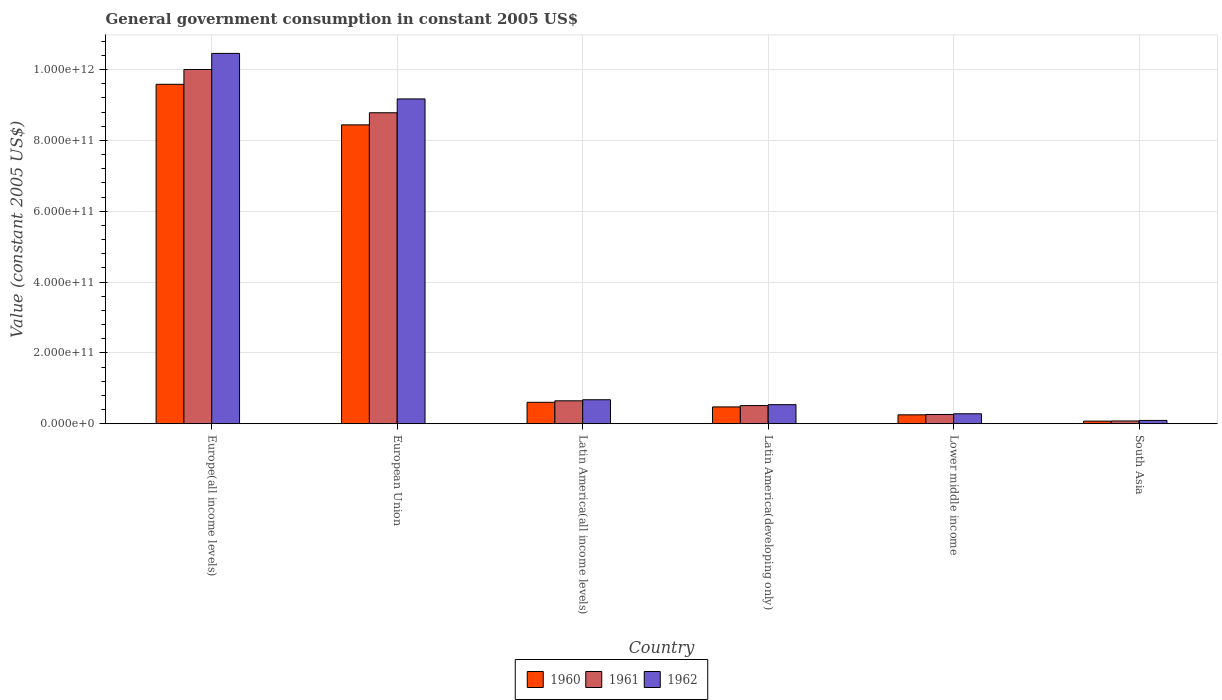Are the number of bars per tick equal to the number of legend labels?
Keep it short and to the point. Yes. How many bars are there on the 4th tick from the right?
Ensure brevity in your answer.  3. What is the label of the 2nd group of bars from the left?
Ensure brevity in your answer.  European Union. What is the government conusmption in 1961 in Latin America(developing only)?
Provide a short and direct response. 5.13e+1. Across all countries, what is the maximum government conusmption in 1960?
Ensure brevity in your answer.  9.58e+11. Across all countries, what is the minimum government conusmption in 1960?
Offer a terse response. 7.34e+09. In which country was the government conusmption in 1962 maximum?
Your answer should be compact. Europe(all income levels). What is the total government conusmption in 1962 in the graph?
Offer a very short reply. 2.12e+12. What is the difference between the government conusmption in 1960 in Latin America(developing only) and that in South Asia?
Ensure brevity in your answer.  4.01e+1. What is the difference between the government conusmption in 1962 in Europe(all income levels) and the government conusmption in 1961 in South Asia?
Offer a very short reply. 1.04e+12. What is the average government conusmption in 1962 per country?
Offer a very short reply. 3.54e+11. What is the difference between the government conusmption of/in 1961 and government conusmption of/in 1962 in Europe(all income levels)?
Ensure brevity in your answer.  -4.54e+1. In how many countries, is the government conusmption in 1960 greater than 760000000000 US$?
Provide a succinct answer. 2. What is the ratio of the government conusmption in 1962 in Latin America(all income levels) to that in Lower middle income?
Offer a terse response. 2.41. Is the government conusmption in 1962 in European Union less than that in South Asia?
Ensure brevity in your answer.  No. What is the difference between the highest and the second highest government conusmption in 1962?
Your answer should be compact. 1.29e+11. What is the difference between the highest and the lowest government conusmption in 1962?
Offer a very short reply. 1.04e+12. In how many countries, is the government conusmption in 1961 greater than the average government conusmption in 1961 taken over all countries?
Your answer should be compact. 2. Is the sum of the government conusmption in 1960 in European Union and Lower middle income greater than the maximum government conusmption in 1962 across all countries?
Offer a very short reply. No. Is it the case that in every country, the sum of the government conusmption in 1962 and government conusmption in 1960 is greater than the government conusmption in 1961?
Give a very brief answer. Yes. What is the difference between two consecutive major ticks on the Y-axis?
Offer a terse response. 2.00e+11. Does the graph contain any zero values?
Your answer should be very brief. No. Does the graph contain grids?
Your answer should be compact. Yes. Where does the legend appear in the graph?
Your answer should be compact. Bottom center. What is the title of the graph?
Your answer should be compact. General government consumption in constant 2005 US$. What is the label or title of the X-axis?
Provide a short and direct response. Country. What is the label or title of the Y-axis?
Provide a short and direct response. Value (constant 2005 US$). What is the Value (constant 2005 US$) in 1960 in Europe(all income levels)?
Offer a very short reply. 9.58e+11. What is the Value (constant 2005 US$) of 1961 in Europe(all income levels)?
Your answer should be very brief. 1.00e+12. What is the Value (constant 2005 US$) of 1962 in Europe(all income levels)?
Ensure brevity in your answer.  1.05e+12. What is the Value (constant 2005 US$) in 1960 in European Union?
Provide a short and direct response. 8.44e+11. What is the Value (constant 2005 US$) in 1961 in European Union?
Provide a short and direct response. 8.78e+11. What is the Value (constant 2005 US$) of 1962 in European Union?
Keep it short and to the point. 9.17e+11. What is the Value (constant 2005 US$) in 1960 in Latin America(all income levels)?
Offer a terse response. 6.06e+1. What is the Value (constant 2005 US$) in 1961 in Latin America(all income levels)?
Make the answer very short. 6.47e+1. What is the Value (constant 2005 US$) of 1962 in Latin America(all income levels)?
Your answer should be compact. 6.77e+1. What is the Value (constant 2005 US$) in 1960 in Latin America(developing only)?
Your response must be concise. 4.75e+1. What is the Value (constant 2005 US$) of 1961 in Latin America(developing only)?
Your answer should be compact. 5.13e+1. What is the Value (constant 2005 US$) in 1962 in Latin America(developing only)?
Provide a succinct answer. 5.38e+1. What is the Value (constant 2005 US$) in 1960 in Lower middle income?
Offer a terse response. 2.52e+1. What is the Value (constant 2005 US$) in 1961 in Lower middle income?
Offer a very short reply. 2.61e+1. What is the Value (constant 2005 US$) in 1962 in Lower middle income?
Ensure brevity in your answer.  2.81e+1. What is the Value (constant 2005 US$) in 1960 in South Asia?
Offer a terse response. 7.34e+09. What is the Value (constant 2005 US$) in 1961 in South Asia?
Give a very brief answer. 7.82e+09. What is the Value (constant 2005 US$) in 1962 in South Asia?
Give a very brief answer. 9.32e+09. Across all countries, what is the maximum Value (constant 2005 US$) in 1960?
Provide a short and direct response. 9.58e+11. Across all countries, what is the maximum Value (constant 2005 US$) in 1961?
Offer a very short reply. 1.00e+12. Across all countries, what is the maximum Value (constant 2005 US$) of 1962?
Offer a very short reply. 1.05e+12. Across all countries, what is the minimum Value (constant 2005 US$) in 1960?
Offer a very short reply. 7.34e+09. Across all countries, what is the minimum Value (constant 2005 US$) of 1961?
Keep it short and to the point. 7.82e+09. Across all countries, what is the minimum Value (constant 2005 US$) of 1962?
Your answer should be compact. 9.32e+09. What is the total Value (constant 2005 US$) in 1960 in the graph?
Your answer should be compact. 1.94e+12. What is the total Value (constant 2005 US$) in 1961 in the graph?
Your response must be concise. 2.03e+12. What is the total Value (constant 2005 US$) in 1962 in the graph?
Make the answer very short. 2.12e+12. What is the difference between the Value (constant 2005 US$) of 1960 in Europe(all income levels) and that in European Union?
Offer a terse response. 1.15e+11. What is the difference between the Value (constant 2005 US$) of 1961 in Europe(all income levels) and that in European Union?
Keep it short and to the point. 1.22e+11. What is the difference between the Value (constant 2005 US$) of 1962 in Europe(all income levels) and that in European Union?
Your answer should be compact. 1.29e+11. What is the difference between the Value (constant 2005 US$) in 1960 in Europe(all income levels) and that in Latin America(all income levels)?
Ensure brevity in your answer.  8.98e+11. What is the difference between the Value (constant 2005 US$) of 1961 in Europe(all income levels) and that in Latin America(all income levels)?
Your response must be concise. 9.35e+11. What is the difference between the Value (constant 2005 US$) in 1962 in Europe(all income levels) and that in Latin America(all income levels)?
Offer a very short reply. 9.78e+11. What is the difference between the Value (constant 2005 US$) in 1960 in Europe(all income levels) and that in Latin America(developing only)?
Your response must be concise. 9.11e+11. What is the difference between the Value (constant 2005 US$) of 1961 in Europe(all income levels) and that in Latin America(developing only)?
Offer a very short reply. 9.49e+11. What is the difference between the Value (constant 2005 US$) of 1962 in Europe(all income levels) and that in Latin America(developing only)?
Make the answer very short. 9.92e+11. What is the difference between the Value (constant 2005 US$) in 1960 in Europe(all income levels) and that in Lower middle income?
Ensure brevity in your answer.  9.33e+11. What is the difference between the Value (constant 2005 US$) in 1961 in Europe(all income levels) and that in Lower middle income?
Your response must be concise. 9.74e+11. What is the difference between the Value (constant 2005 US$) of 1962 in Europe(all income levels) and that in Lower middle income?
Your response must be concise. 1.02e+12. What is the difference between the Value (constant 2005 US$) in 1960 in Europe(all income levels) and that in South Asia?
Offer a terse response. 9.51e+11. What is the difference between the Value (constant 2005 US$) in 1961 in Europe(all income levels) and that in South Asia?
Provide a short and direct response. 9.92e+11. What is the difference between the Value (constant 2005 US$) in 1962 in Europe(all income levels) and that in South Asia?
Provide a short and direct response. 1.04e+12. What is the difference between the Value (constant 2005 US$) of 1960 in European Union and that in Latin America(all income levels)?
Give a very brief answer. 7.83e+11. What is the difference between the Value (constant 2005 US$) in 1961 in European Union and that in Latin America(all income levels)?
Make the answer very short. 8.13e+11. What is the difference between the Value (constant 2005 US$) of 1962 in European Union and that in Latin America(all income levels)?
Your response must be concise. 8.49e+11. What is the difference between the Value (constant 2005 US$) of 1960 in European Union and that in Latin America(developing only)?
Your answer should be very brief. 7.96e+11. What is the difference between the Value (constant 2005 US$) in 1961 in European Union and that in Latin America(developing only)?
Provide a succinct answer. 8.27e+11. What is the difference between the Value (constant 2005 US$) in 1962 in European Union and that in Latin America(developing only)?
Make the answer very short. 8.63e+11. What is the difference between the Value (constant 2005 US$) in 1960 in European Union and that in Lower middle income?
Keep it short and to the point. 8.19e+11. What is the difference between the Value (constant 2005 US$) of 1961 in European Union and that in Lower middle income?
Your answer should be very brief. 8.52e+11. What is the difference between the Value (constant 2005 US$) in 1962 in European Union and that in Lower middle income?
Keep it short and to the point. 8.89e+11. What is the difference between the Value (constant 2005 US$) of 1960 in European Union and that in South Asia?
Your answer should be very brief. 8.36e+11. What is the difference between the Value (constant 2005 US$) of 1961 in European Union and that in South Asia?
Your response must be concise. 8.70e+11. What is the difference between the Value (constant 2005 US$) of 1962 in European Union and that in South Asia?
Provide a succinct answer. 9.08e+11. What is the difference between the Value (constant 2005 US$) of 1960 in Latin America(all income levels) and that in Latin America(developing only)?
Your response must be concise. 1.31e+1. What is the difference between the Value (constant 2005 US$) of 1961 in Latin America(all income levels) and that in Latin America(developing only)?
Provide a short and direct response. 1.35e+1. What is the difference between the Value (constant 2005 US$) of 1962 in Latin America(all income levels) and that in Latin America(developing only)?
Your answer should be compact. 1.39e+1. What is the difference between the Value (constant 2005 US$) of 1960 in Latin America(all income levels) and that in Lower middle income?
Offer a very short reply. 3.54e+1. What is the difference between the Value (constant 2005 US$) in 1961 in Latin America(all income levels) and that in Lower middle income?
Your answer should be very brief. 3.86e+1. What is the difference between the Value (constant 2005 US$) of 1962 in Latin America(all income levels) and that in Lower middle income?
Offer a terse response. 3.96e+1. What is the difference between the Value (constant 2005 US$) of 1960 in Latin America(all income levels) and that in South Asia?
Ensure brevity in your answer.  5.32e+1. What is the difference between the Value (constant 2005 US$) of 1961 in Latin America(all income levels) and that in South Asia?
Provide a succinct answer. 5.69e+1. What is the difference between the Value (constant 2005 US$) in 1962 in Latin America(all income levels) and that in South Asia?
Give a very brief answer. 5.84e+1. What is the difference between the Value (constant 2005 US$) of 1960 in Latin America(developing only) and that in Lower middle income?
Offer a very short reply. 2.23e+1. What is the difference between the Value (constant 2005 US$) of 1961 in Latin America(developing only) and that in Lower middle income?
Provide a succinct answer. 2.52e+1. What is the difference between the Value (constant 2005 US$) in 1962 in Latin America(developing only) and that in Lower middle income?
Offer a terse response. 2.57e+1. What is the difference between the Value (constant 2005 US$) of 1960 in Latin America(developing only) and that in South Asia?
Keep it short and to the point. 4.01e+1. What is the difference between the Value (constant 2005 US$) in 1961 in Latin America(developing only) and that in South Asia?
Your answer should be very brief. 4.35e+1. What is the difference between the Value (constant 2005 US$) in 1962 in Latin America(developing only) and that in South Asia?
Your answer should be compact. 4.45e+1. What is the difference between the Value (constant 2005 US$) of 1960 in Lower middle income and that in South Asia?
Your answer should be very brief. 1.78e+1. What is the difference between the Value (constant 2005 US$) in 1961 in Lower middle income and that in South Asia?
Your answer should be very brief. 1.83e+1. What is the difference between the Value (constant 2005 US$) in 1962 in Lower middle income and that in South Asia?
Give a very brief answer. 1.88e+1. What is the difference between the Value (constant 2005 US$) in 1960 in Europe(all income levels) and the Value (constant 2005 US$) in 1961 in European Union?
Make the answer very short. 8.03e+1. What is the difference between the Value (constant 2005 US$) of 1960 in Europe(all income levels) and the Value (constant 2005 US$) of 1962 in European Union?
Provide a short and direct response. 4.13e+1. What is the difference between the Value (constant 2005 US$) in 1961 in Europe(all income levels) and the Value (constant 2005 US$) in 1962 in European Union?
Offer a very short reply. 8.31e+1. What is the difference between the Value (constant 2005 US$) of 1960 in Europe(all income levels) and the Value (constant 2005 US$) of 1961 in Latin America(all income levels)?
Provide a succinct answer. 8.94e+11. What is the difference between the Value (constant 2005 US$) of 1960 in Europe(all income levels) and the Value (constant 2005 US$) of 1962 in Latin America(all income levels)?
Give a very brief answer. 8.91e+11. What is the difference between the Value (constant 2005 US$) in 1961 in Europe(all income levels) and the Value (constant 2005 US$) in 1962 in Latin America(all income levels)?
Your response must be concise. 9.32e+11. What is the difference between the Value (constant 2005 US$) in 1960 in Europe(all income levels) and the Value (constant 2005 US$) in 1961 in Latin America(developing only)?
Provide a short and direct response. 9.07e+11. What is the difference between the Value (constant 2005 US$) in 1960 in Europe(all income levels) and the Value (constant 2005 US$) in 1962 in Latin America(developing only)?
Offer a very short reply. 9.05e+11. What is the difference between the Value (constant 2005 US$) of 1961 in Europe(all income levels) and the Value (constant 2005 US$) of 1962 in Latin America(developing only)?
Offer a terse response. 9.46e+11. What is the difference between the Value (constant 2005 US$) of 1960 in Europe(all income levels) and the Value (constant 2005 US$) of 1961 in Lower middle income?
Offer a very short reply. 9.32e+11. What is the difference between the Value (constant 2005 US$) in 1960 in Europe(all income levels) and the Value (constant 2005 US$) in 1962 in Lower middle income?
Give a very brief answer. 9.30e+11. What is the difference between the Value (constant 2005 US$) in 1961 in Europe(all income levels) and the Value (constant 2005 US$) in 1962 in Lower middle income?
Ensure brevity in your answer.  9.72e+11. What is the difference between the Value (constant 2005 US$) in 1960 in Europe(all income levels) and the Value (constant 2005 US$) in 1961 in South Asia?
Your answer should be very brief. 9.51e+11. What is the difference between the Value (constant 2005 US$) in 1960 in Europe(all income levels) and the Value (constant 2005 US$) in 1962 in South Asia?
Offer a very short reply. 9.49e+11. What is the difference between the Value (constant 2005 US$) in 1961 in Europe(all income levels) and the Value (constant 2005 US$) in 1962 in South Asia?
Make the answer very short. 9.91e+11. What is the difference between the Value (constant 2005 US$) in 1960 in European Union and the Value (constant 2005 US$) in 1961 in Latin America(all income levels)?
Provide a succinct answer. 7.79e+11. What is the difference between the Value (constant 2005 US$) of 1960 in European Union and the Value (constant 2005 US$) of 1962 in Latin America(all income levels)?
Your response must be concise. 7.76e+11. What is the difference between the Value (constant 2005 US$) of 1961 in European Union and the Value (constant 2005 US$) of 1962 in Latin America(all income levels)?
Make the answer very short. 8.10e+11. What is the difference between the Value (constant 2005 US$) of 1960 in European Union and the Value (constant 2005 US$) of 1961 in Latin America(developing only)?
Offer a terse response. 7.93e+11. What is the difference between the Value (constant 2005 US$) of 1960 in European Union and the Value (constant 2005 US$) of 1962 in Latin America(developing only)?
Provide a short and direct response. 7.90e+11. What is the difference between the Value (constant 2005 US$) in 1961 in European Union and the Value (constant 2005 US$) in 1962 in Latin America(developing only)?
Your response must be concise. 8.24e+11. What is the difference between the Value (constant 2005 US$) in 1960 in European Union and the Value (constant 2005 US$) in 1961 in Lower middle income?
Provide a short and direct response. 8.18e+11. What is the difference between the Value (constant 2005 US$) in 1960 in European Union and the Value (constant 2005 US$) in 1962 in Lower middle income?
Your answer should be compact. 8.16e+11. What is the difference between the Value (constant 2005 US$) of 1961 in European Union and the Value (constant 2005 US$) of 1962 in Lower middle income?
Keep it short and to the point. 8.50e+11. What is the difference between the Value (constant 2005 US$) in 1960 in European Union and the Value (constant 2005 US$) in 1961 in South Asia?
Keep it short and to the point. 8.36e+11. What is the difference between the Value (constant 2005 US$) in 1960 in European Union and the Value (constant 2005 US$) in 1962 in South Asia?
Offer a terse response. 8.35e+11. What is the difference between the Value (constant 2005 US$) in 1961 in European Union and the Value (constant 2005 US$) in 1962 in South Asia?
Offer a very short reply. 8.69e+11. What is the difference between the Value (constant 2005 US$) of 1960 in Latin America(all income levels) and the Value (constant 2005 US$) of 1961 in Latin America(developing only)?
Your response must be concise. 9.29e+09. What is the difference between the Value (constant 2005 US$) in 1960 in Latin America(all income levels) and the Value (constant 2005 US$) in 1962 in Latin America(developing only)?
Make the answer very short. 6.76e+09. What is the difference between the Value (constant 2005 US$) in 1961 in Latin America(all income levels) and the Value (constant 2005 US$) in 1962 in Latin America(developing only)?
Make the answer very short. 1.09e+1. What is the difference between the Value (constant 2005 US$) in 1960 in Latin America(all income levels) and the Value (constant 2005 US$) in 1961 in Lower middle income?
Provide a succinct answer. 3.45e+1. What is the difference between the Value (constant 2005 US$) in 1960 in Latin America(all income levels) and the Value (constant 2005 US$) in 1962 in Lower middle income?
Your answer should be very brief. 3.25e+1. What is the difference between the Value (constant 2005 US$) of 1961 in Latin America(all income levels) and the Value (constant 2005 US$) of 1962 in Lower middle income?
Keep it short and to the point. 3.66e+1. What is the difference between the Value (constant 2005 US$) in 1960 in Latin America(all income levels) and the Value (constant 2005 US$) in 1961 in South Asia?
Keep it short and to the point. 5.28e+1. What is the difference between the Value (constant 2005 US$) of 1960 in Latin America(all income levels) and the Value (constant 2005 US$) of 1962 in South Asia?
Offer a very short reply. 5.12e+1. What is the difference between the Value (constant 2005 US$) of 1961 in Latin America(all income levels) and the Value (constant 2005 US$) of 1962 in South Asia?
Your answer should be compact. 5.54e+1. What is the difference between the Value (constant 2005 US$) of 1960 in Latin America(developing only) and the Value (constant 2005 US$) of 1961 in Lower middle income?
Give a very brief answer. 2.14e+1. What is the difference between the Value (constant 2005 US$) of 1960 in Latin America(developing only) and the Value (constant 2005 US$) of 1962 in Lower middle income?
Your answer should be compact. 1.94e+1. What is the difference between the Value (constant 2005 US$) of 1961 in Latin America(developing only) and the Value (constant 2005 US$) of 1962 in Lower middle income?
Provide a succinct answer. 2.32e+1. What is the difference between the Value (constant 2005 US$) in 1960 in Latin America(developing only) and the Value (constant 2005 US$) in 1961 in South Asia?
Your answer should be very brief. 3.97e+1. What is the difference between the Value (constant 2005 US$) of 1960 in Latin America(developing only) and the Value (constant 2005 US$) of 1962 in South Asia?
Ensure brevity in your answer.  3.82e+1. What is the difference between the Value (constant 2005 US$) in 1961 in Latin America(developing only) and the Value (constant 2005 US$) in 1962 in South Asia?
Offer a terse response. 4.20e+1. What is the difference between the Value (constant 2005 US$) in 1960 in Lower middle income and the Value (constant 2005 US$) in 1961 in South Asia?
Make the answer very short. 1.74e+1. What is the difference between the Value (constant 2005 US$) of 1960 in Lower middle income and the Value (constant 2005 US$) of 1962 in South Asia?
Offer a very short reply. 1.59e+1. What is the difference between the Value (constant 2005 US$) of 1961 in Lower middle income and the Value (constant 2005 US$) of 1962 in South Asia?
Make the answer very short. 1.68e+1. What is the average Value (constant 2005 US$) of 1960 per country?
Offer a very short reply. 3.24e+11. What is the average Value (constant 2005 US$) of 1961 per country?
Make the answer very short. 3.38e+11. What is the average Value (constant 2005 US$) in 1962 per country?
Provide a short and direct response. 3.54e+11. What is the difference between the Value (constant 2005 US$) of 1960 and Value (constant 2005 US$) of 1961 in Europe(all income levels)?
Provide a short and direct response. -4.18e+1. What is the difference between the Value (constant 2005 US$) of 1960 and Value (constant 2005 US$) of 1962 in Europe(all income levels)?
Offer a terse response. -8.73e+1. What is the difference between the Value (constant 2005 US$) in 1961 and Value (constant 2005 US$) in 1962 in Europe(all income levels)?
Keep it short and to the point. -4.54e+1. What is the difference between the Value (constant 2005 US$) in 1960 and Value (constant 2005 US$) in 1961 in European Union?
Ensure brevity in your answer.  -3.42e+1. What is the difference between the Value (constant 2005 US$) of 1960 and Value (constant 2005 US$) of 1962 in European Union?
Make the answer very short. -7.32e+1. What is the difference between the Value (constant 2005 US$) of 1961 and Value (constant 2005 US$) of 1962 in European Union?
Give a very brief answer. -3.90e+1. What is the difference between the Value (constant 2005 US$) of 1960 and Value (constant 2005 US$) of 1961 in Latin America(all income levels)?
Offer a very short reply. -4.16e+09. What is the difference between the Value (constant 2005 US$) of 1960 and Value (constant 2005 US$) of 1962 in Latin America(all income levels)?
Give a very brief answer. -7.17e+09. What is the difference between the Value (constant 2005 US$) of 1961 and Value (constant 2005 US$) of 1962 in Latin America(all income levels)?
Make the answer very short. -3.01e+09. What is the difference between the Value (constant 2005 US$) in 1960 and Value (constant 2005 US$) in 1961 in Latin America(developing only)?
Offer a very short reply. -3.79e+09. What is the difference between the Value (constant 2005 US$) in 1960 and Value (constant 2005 US$) in 1962 in Latin America(developing only)?
Provide a succinct answer. -6.32e+09. What is the difference between the Value (constant 2005 US$) in 1961 and Value (constant 2005 US$) in 1962 in Latin America(developing only)?
Keep it short and to the point. -2.53e+09. What is the difference between the Value (constant 2005 US$) of 1960 and Value (constant 2005 US$) of 1961 in Lower middle income?
Ensure brevity in your answer.  -9.46e+08. What is the difference between the Value (constant 2005 US$) of 1960 and Value (constant 2005 US$) of 1962 in Lower middle income?
Your answer should be very brief. -2.95e+09. What is the difference between the Value (constant 2005 US$) in 1961 and Value (constant 2005 US$) in 1962 in Lower middle income?
Offer a very short reply. -2.00e+09. What is the difference between the Value (constant 2005 US$) in 1960 and Value (constant 2005 US$) in 1961 in South Asia?
Provide a short and direct response. -4.76e+08. What is the difference between the Value (constant 2005 US$) in 1960 and Value (constant 2005 US$) in 1962 in South Asia?
Provide a short and direct response. -1.98e+09. What is the difference between the Value (constant 2005 US$) in 1961 and Value (constant 2005 US$) in 1962 in South Asia?
Make the answer very short. -1.50e+09. What is the ratio of the Value (constant 2005 US$) of 1960 in Europe(all income levels) to that in European Union?
Provide a short and direct response. 1.14. What is the ratio of the Value (constant 2005 US$) in 1961 in Europe(all income levels) to that in European Union?
Offer a very short reply. 1.14. What is the ratio of the Value (constant 2005 US$) of 1962 in Europe(all income levels) to that in European Union?
Offer a terse response. 1.14. What is the ratio of the Value (constant 2005 US$) of 1960 in Europe(all income levels) to that in Latin America(all income levels)?
Give a very brief answer. 15.82. What is the ratio of the Value (constant 2005 US$) in 1961 in Europe(all income levels) to that in Latin America(all income levels)?
Offer a very short reply. 15.45. What is the ratio of the Value (constant 2005 US$) in 1962 in Europe(all income levels) to that in Latin America(all income levels)?
Offer a very short reply. 15.43. What is the ratio of the Value (constant 2005 US$) in 1960 in Europe(all income levels) to that in Latin America(developing only)?
Keep it short and to the point. 20.18. What is the ratio of the Value (constant 2005 US$) in 1961 in Europe(all income levels) to that in Latin America(developing only)?
Provide a succinct answer. 19.5. What is the ratio of the Value (constant 2005 US$) of 1962 in Europe(all income levels) to that in Latin America(developing only)?
Your answer should be compact. 19.43. What is the ratio of the Value (constant 2005 US$) in 1960 in Europe(all income levels) to that in Lower middle income?
Give a very brief answer. 38.07. What is the ratio of the Value (constant 2005 US$) of 1961 in Europe(all income levels) to that in Lower middle income?
Your answer should be compact. 38.29. What is the ratio of the Value (constant 2005 US$) in 1962 in Europe(all income levels) to that in Lower middle income?
Make the answer very short. 37.18. What is the ratio of the Value (constant 2005 US$) in 1960 in Europe(all income levels) to that in South Asia?
Ensure brevity in your answer.  130.49. What is the ratio of the Value (constant 2005 US$) of 1961 in Europe(all income levels) to that in South Asia?
Provide a short and direct response. 127.9. What is the ratio of the Value (constant 2005 US$) of 1962 in Europe(all income levels) to that in South Asia?
Keep it short and to the point. 112.16. What is the ratio of the Value (constant 2005 US$) of 1960 in European Union to that in Latin America(all income levels)?
Ensure brevity in your answer.  13.93. What is the ratio of the Value (constant 2005 US$) of 1961 in European Union to that in Latin America(all income levels)?
Your response must be concise. 13.56. What is the ratio of the Value (constant 2005 US$) of 1962 in European Union to that in Latin America(all income levels)?
Offer a terse response. 13.54. What is the ratio of the Value (constant 2005 US$) in 1960 in European Union to that in Latin America(developing only)?
Offer a very short reply. 17.77. What is the ratio of the Value (constant 2005 US$) of 1961 in European Union to that in Latin America(developing only)?
Ensure brevity in your answer.  17.12. What is the ratio of the Value (constant 2005 US$) of 1962 in European Union to that in Latin America(developing only)?
Provide a succinct answer. 17.04. What is the ratio of the Value (constant 2005 US$) in 1960 in European Union to that in Lower middle income?
Give a very brief answer. 33.52. What is the ratio of the Value (constant 2005 US$) of 1961 in European Union to that in Lower middle income?
Provide a short and direct response. 33.61. What is the ratio of the Value (constant 2005 US$) of 1962 in European Union to that in Lower middle income?
Ensure brevity in your answer.  32.61. What is the ratio of the Value (constant 2005 US$) of 1960 in European Union to that in South Asia?
Provide a short and direct response. 114.9. What is the ratio of the Value (constant 2005 US$) in 1961 in European Union to that in South Asia?
Ensure brevity in your answer.  112.28. What is the ratio of the Value (constant 2005 US$) of 1962 in European Union to that in South Asia?
Provide a short and direct response. 98.37. What is the ratio of the Value (constant 2005 US$) in 1960 in Latin America(all income levels) to that in Latin America(developing only)?
Offer a terse response. 1.28. What is the ratio of the Value (constant 2005 US$) of 1961 in Latin America(all income levels) to that in Latin America(developing only)?
Provide a short and direct response. 1.26. What is the ratio of the Value (constant 2005 US$) in 1962 in Latin America(all income levels) to that in Latin America(developing only)?
Offer a very short reply. 1.26. What is the ratio of the Value (constant 2005 US$) in 1960 in Latin America(all income levels) to that in Lower middle income?
Ensure brevity in your answer.  2.41. What is the ratio of the Value (constant 2005 US$) of 1961 in Latin America(all income levels) to that in Lower middle income?
Ensure brevity in your answer.  2.48. What is the ratio of the Value (constant 2005 US$) in 1962 in Latin America(all income levels) to that in Lower middle income?
Ensure brevity in your answer.  2.41. What is the ratio of the Value (constant 2005 US$) of 1960 in Latin America(all income levels) to that in South Asia?
Offer a very short reply. 8.25. What is the ratio of the Value (constant 2005 US$) of 1961 in Latin America(all income levels) to that in South Asia?
Your answer should be compact. 8.28. What is the ratio of the Value (constant 2005 US$) of 1962 in Latin America(all income levels) to that in South Asia?
Your response must be concise. 7.27. What is the ratio of the Value (constant 2005 US$) of 1960 in Latin America(developing only) to that in Lower middle income?
Offer a very short reply. 1.89. What is the ratio of the Value (constant 2005 US$) of 1961 in Latin America(developing only) to that in Lower middle income?
Your answer should be very brief. 1.96. What is the ratio of the Value (constant 2005 US$) of 1962 in Latin America(developing only) to that in Lower middle income?
Your answer should be compact. 1.91. What is the ratio of the Value (constant 2005 US$) in 1960 in Latin America(developing only) to that in South Asia?
Your response must be concise. 6.47. What is the ratio of the Value (constant 2005 US$) of 1961 in Latin America(developing only) to that in South Asia?
Make the answer very short. 6.56. What is the ratio of the Value (constant 2005 US$) in 1962 in Latin America(developing only) to that in South Asia?
Provide a short and direct response. 5.77. What is the ratio of the Value (constant 2005 US$) in 1960 in Lower middle income to that in South Asia?
Offer a very short reply. 3.43. What is the ratio of the Value (constant 2005 US$) in 1961 in Lower middle income to that in South Asia?
Your response must be concise. 3.34. What is the ratio of the Value (constant 2005 US$) in 1962 in Lower middle income to that in South Asia?
Ensure brevity in your answer.  3.02. What is the difference between the highest and the second highest Value (constant 2005 US$) in 1960?
Your answer should be very brief. 1.15e+11. What is the difference between the highest and the second highest Value (constant 2005 US$) in 1961?
Keep it short and to the point. 1.22e+11. What is the difference between the highest and the second highest Value (constant 2005 US$) in 1962?
Provide a short and direct response. 1.29e+11. What is the difference between the highest and the lowest Value (constant 2005 US$) in 1960?
Offer a very short reply. 9.51e+11. What is the difference between the highest and the lowest Value (constant 2005 US$) in 1961?
Make the answer very short. 9.92e+11. What is the difference between the highest and the lowest Value (constant 2005 US$) in 1962?
Offer a very short reply. 1.04e+12. 